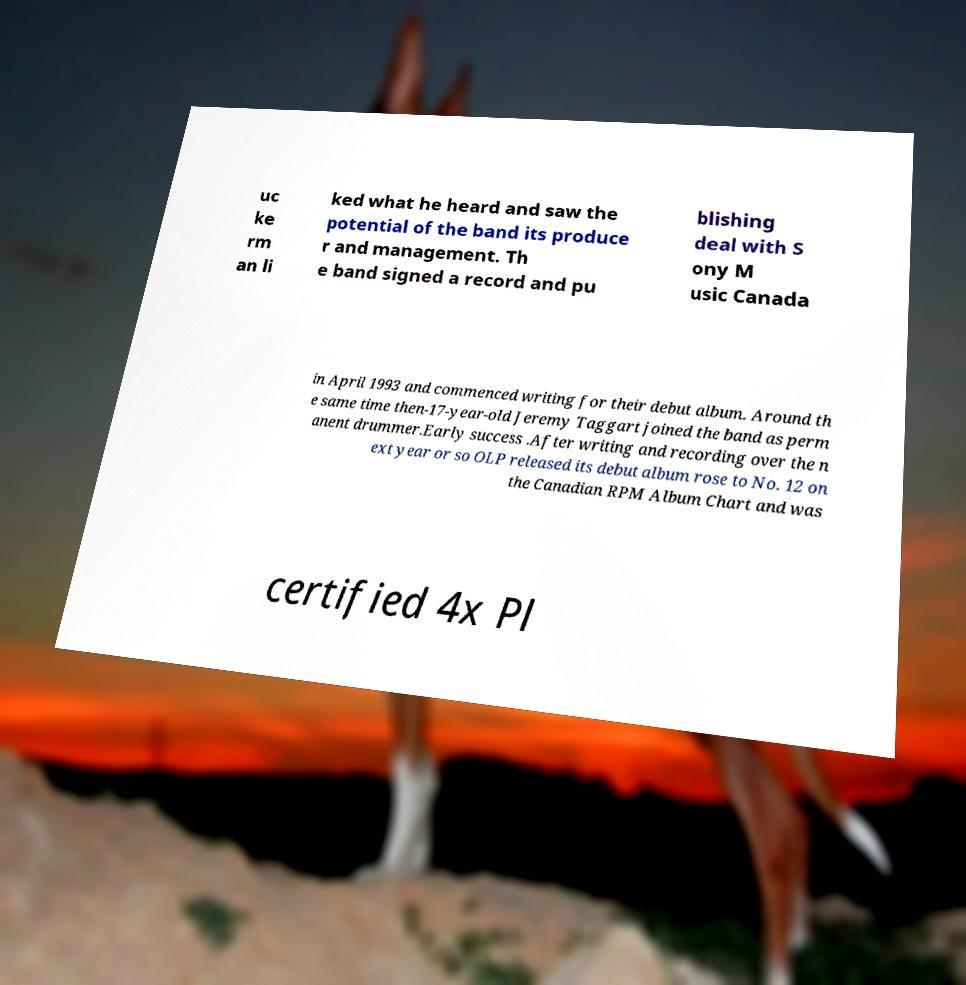Please identify and transcribe the text found in this image. uc ke rm an li ked what he heard and saw the potential of the band its produce r and management. Th e band signed a record and pu blishing deal with S ony M usic Canada in April 1993 and commenced writing for their debut album. Around th e same time then-17-year-old Jeremy Taggart joined the band as perm anent drummer.Early success .After writing and recording over the n ext year or so OLP released its debut album rose to No. 12 on the Canadian RPM Album Chart and was certified 4x Pl 